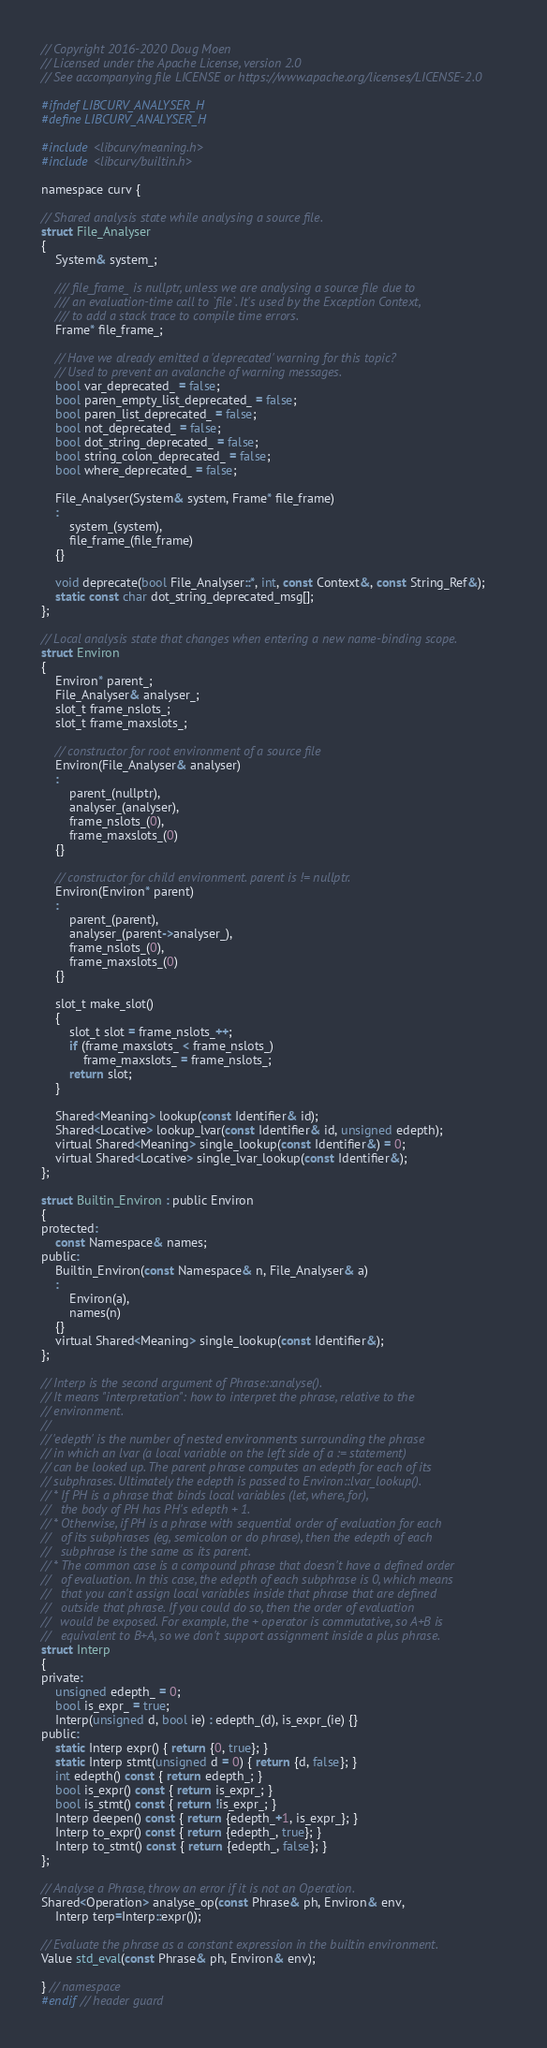Convert code to text. <code><loc_0><loc_0><loc_500><loc_500><_C_>// Copyright 2016-2020 Doug Moen
// Licensed under the Apache License, version 2.0
// See accompanying file LICENSE or https://www.apache.org/licenses/LICENSE-2.0

#ifndef LIBCURV_ANALYSER_H
#define LIBCURV_ANALYSER_H

#include <libcurv/meaning.h>
#include <libcurv/builtin.h>

namespace curv {

// Shared analysis state while analysing a source file.
struct File_Analyser
{
    System& system_;

    /// file_frame_ is nullptr, unless we are analysing a source file due to
    /// an evaluation-time call to `file`. It's used by the Exception Context,
    /// to add a stack trace to compile time errors.
    Frame* file_frame_;

    // Have we already emitted a 'deprecated' warning for this topic?
    // Used to prevent an avalanche of warning messages.
    bool var_deprecated_ = false;
    bool paren_empty_list_deprecated_ = false;
    bool paren_list_deprecated_ = false;
    bool not_deprecated_ = false;
    bool dot_string_deprecated_ = false;
    bool string_colon_deprecated_ = false;
    bool where_deprecated_ = false;

    File_Analyser(System& system, Frame* file_frame)
    :
        system_(system),
        file_frame_(file_frame)
    {}

    void deprecate(bool File_Analyser::*, int, const Context&, const String_Ref&);
    static const char dot_string_deprecated_msg[];
};

// Local analysis state that changes when entering a new name-binding scope.
struct Environ
{
    Environ* parent_;
    File_Analyser& analyser_;
    slot_t frame_nslots_;
    slot_t frame_maxslots_;

    // constructor for root environment of a source file
    Environ(File_Analyser& analyser)
    :
        parent_(nullptr),
        analyser_(analyser),
        frame_nslots_(0),
        frame_maxslots_(0)
    {}

    // constructor for child environment. parent is != nullptr.
    Environ(Environ* parent)
    :
        parent_(parent),
        analyser_(parent->analyser_),
        frame_nslots_(0),
        frame_maxslots_(0)
    {}

    slot_t make_slot()
    {
        slot_t slot = frame_nslots_++;
        if (frame_maxslots_ < frame_nslots_)
            frame_maxslots_ = frame_nslots_;
        return slot;
    }

    Shared<Meaning> lookup(const Identifier& id);
    Shared<Locative> lookup_lvar(const Identifier& id, unsigned edepth);
    virtual Shared<Meaning> single_lookup(const Identifier&) = 0;
    virtual Shared<Locative> single_lvar_lookup(const Identifier&);
};

struct Builtin_Environ : public Environ
{
protected:
    const Namespace& names;
public:
    Builtin_Environ(const Namespace& n, File_Analyser& a)
    :
        Environ(a),
        names(n)
    {}
    virtual Shared<Meaning> single_lookup(const Identifier&);
};

// Interp is the second argument of Phrase::analyse().
// It means "interpretation": how to interpret the phrase, relative to the
// environment.
//
// 'edepth' is the number of nested environments surrounding the phrase
// in which an lvar (a local variable on the left side of a := statement)
// can be looked up. The parent phrase computes an edepth for each of its
// subphrases. Ultimately the edepth is passed to Environ::lvar_lookup().
// * If PH is a phrase that binds local variables (let, where, for),
//   the body of PH has PH's edepth + 1.
// * Otherwise, if PH is a phrase with sequential order of evaluation for each
//   of its subphrases (eg, semicolon or do phrase), then the edepth of each
//   subphrase is the same as its parent.
// * The common case is a compound phrase that doesn't have a defined order
//   of evaluation. In this case, the edepth of each subphrase is 0, which means
//   that you can't assign local variables inside that phrase that are defined
//   outside that phrase. If you could do so, then the order of evaluation
//   would be exposed. For example, the + operator is commutative, so A+B is
//   equivalent to B+A, so we don't support assignment inside a plus phrase.
struct Interp
{
private:
    unsigned edepth_ = 0;
    bool is_expr_ = true;
    Interp(unsigned d, bool ie) : edepth_(d), is_expr_(ie) {}
public:
    static Interp expr() { return {0, true}; }
    static Interp stmt(unsigned d = 0) { return {d, false}; }
    int edepth() const { return edepth_; }
    bool is_expr() const { return is_expr_; }
    bool is_stmt() const { return !is_expr_; }
    Interp deepen() const { return {edepth_+1, is_expr_}; }
    Interp to_expr() const { return {edepth_, true}; }
    Interp to_stmt() const { return {edepth_, false}; }
};

// Analyse a Phrase, throw an error if it is not an Operation.
Shared<Operation> analyse_op(const Phrase& ph, Environ& env,
    Interp terp=Interp::expr());

// Evaluate the phrase as a constant expression in the builtin environment.
Value std_eval(const Phrase& ph, Environ& env);

} // namespace
#endif // header guard
</code> 